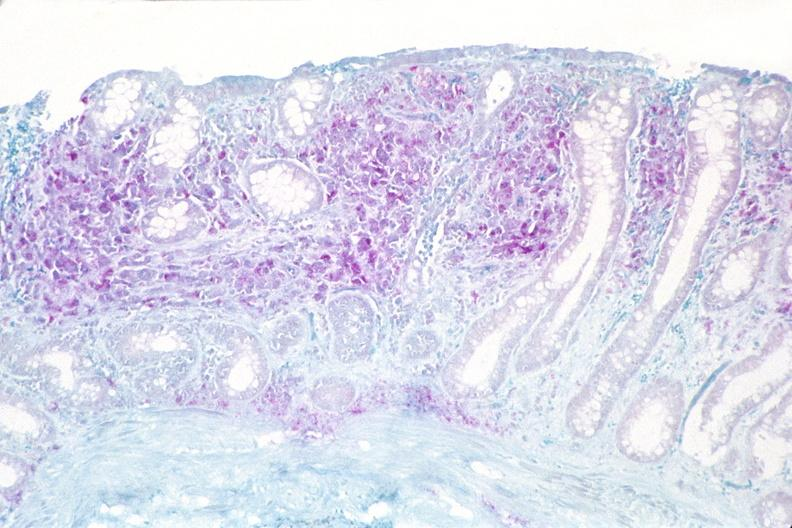does another fiber other frame show colon biopsy, mycobacterium avium-intracellularae?
Answer the question using a single word or phrase. No 